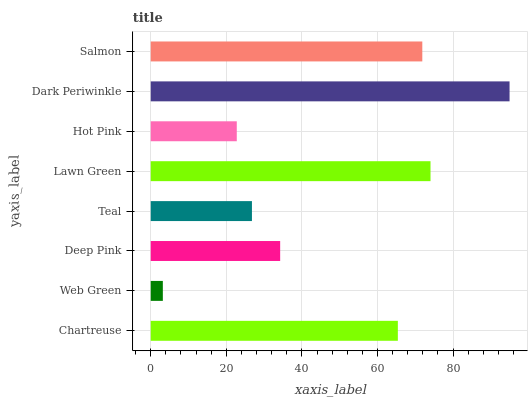Is Web Green the minimum?
Answer yes or no. Yes. Is Dark Periwinkle the maximum?
Answer yes or no. Yes. Is Deep Pink the minimum?
Answer yes or no. No. Is Deep Pink the maximum?
Answer yes or no. No. Is Deep Pink greater than Web Green?
Answer yes or no. Yes. Is Web Green less than Deep Pink?
Answer yes or no. Yes. Is Web Green greater than Deep Pink?
Answer yes or no. No. Is Deep Pink less than Web Green?
Answer yes or no. No. Is Chartreuse the high median?
Answer yes or no. Yes. Is Deep Pink the low median?
Answer yes or no. Yes. Is Web Green the high median?
Answer yes or no. No. Is Web Green the low median?
Answer yes or no. No. 